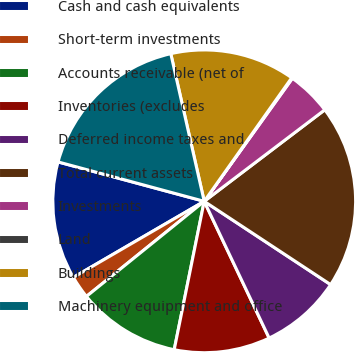<chart> <loc_0><loc_0><loc_500><loc_500><pie_chart><fcel>Cash and cash equivalents<fcel>Short-term investments<fcel>Accounts receivable (net of<fcel>Inventories (excludes<fcel>Deferred income taxes and<fcel>Total current assets<fcel>Investments<fcel>Land<fcel>Buildings<fcel>Machinery equipment and office<nl><fcel>12.57%<fcel>2.43%<fcel>11.01%<fcel>10.23%<fcel>8.67%<fcel>19.6%<fcel>4.77%<fcel>0.09%<fcel>13.35%<fcel>17.26%<nl></chart> 